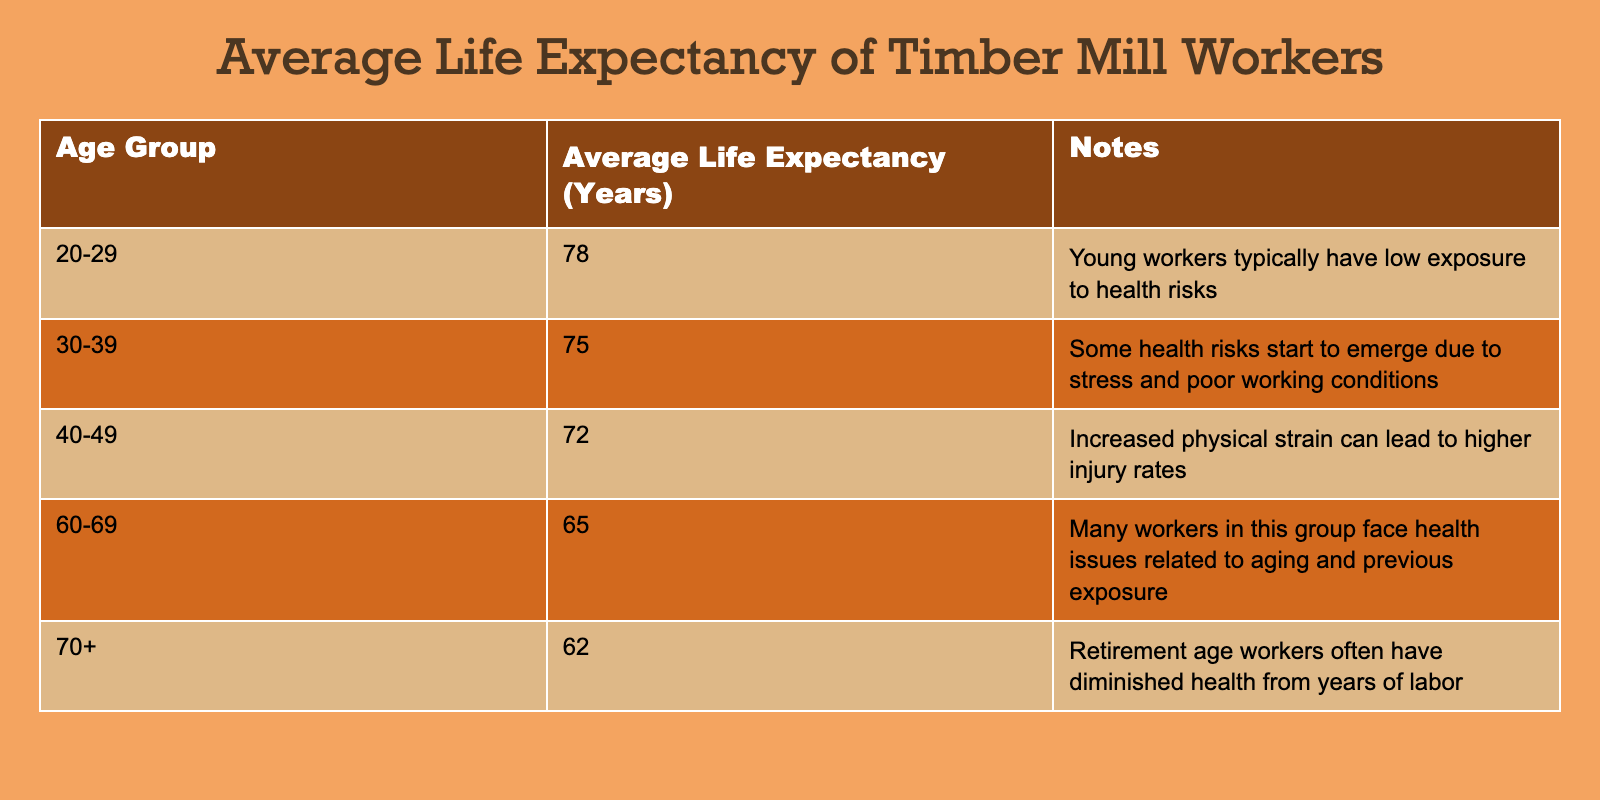What is the average life expectancy of workers in the age group 20-29? The average life expectancy for workers aged 20-29 is listed directly in the table as 78 years.
Answer: 78 What is the average life expectancy for the age group 60-69? The table shows that workers aged 60-69 have an average life expectancy of 65 years.
Answer: 65 Is the average life expectancy of workers aged 70+ higher than that of workers aged 50-59? The table does not provide data for the 50-59 age group, making it impossible to compare the average life expectancy for workers aged 70+ (62 years) with that group. Therefore, the answer is no.
Answer: No What is the difference in average life expectancy between the age groups 40-49 and 30-39? The average life expectancy for age group 40-49 is 72 years, and for 30-39 it is 75 years. The difference is 75 - 72 = 3 years.
Answer: 3 If we average the life expectancy of all age groups listed, what is the result? To find the average, sum the life expectancies: 78 + 75 + 72 + 65 + 62 = 352. There are 5 age groups, so the average is 352 / 5 = 70.4 years.
Answer: 70.4 What is the average life expectancy for the age bracket 40-49 compared to 20-29? The average life expectancy for 40-49 is 72 years, while for 20-29, it is 78 years. Comparing these, 72 is less than 78, indicating that as workers age, their life expectancy tends to decrease.
Answer: 72 is less than 78 True or False: Older workers in the age group 60-69 have the highest average life expectancy among those younger than them. The 60-69 age group has an average life expectancy of 65 years, while all younger age groups (20-29 at 78, 30-39 at 75, and 40-49 at 72) have higher life expectancies. Therefore, the statement is false.
Answer: False What is the average life expectancy of workers from age groups 30-39 and 40-49 combined? The average life expectancies for these groups are 75 years (30-39) and 72 years (40-49). To find the combined average, sum these two values (75 + 72 = 147) and divide by 2. The result is 147 / 2 = 73.5 years.
Answer: 73.5 How does the life expectancy of the 70+ age group compare to the 20-29 age group? The life expectancy for the 70+ age group is 62 years, while the 20-29 age group has an average of 78 years. This clearly shows that the 70+ group has a lower life expectancy compared to the 20-29 group.
Answer: Lower 